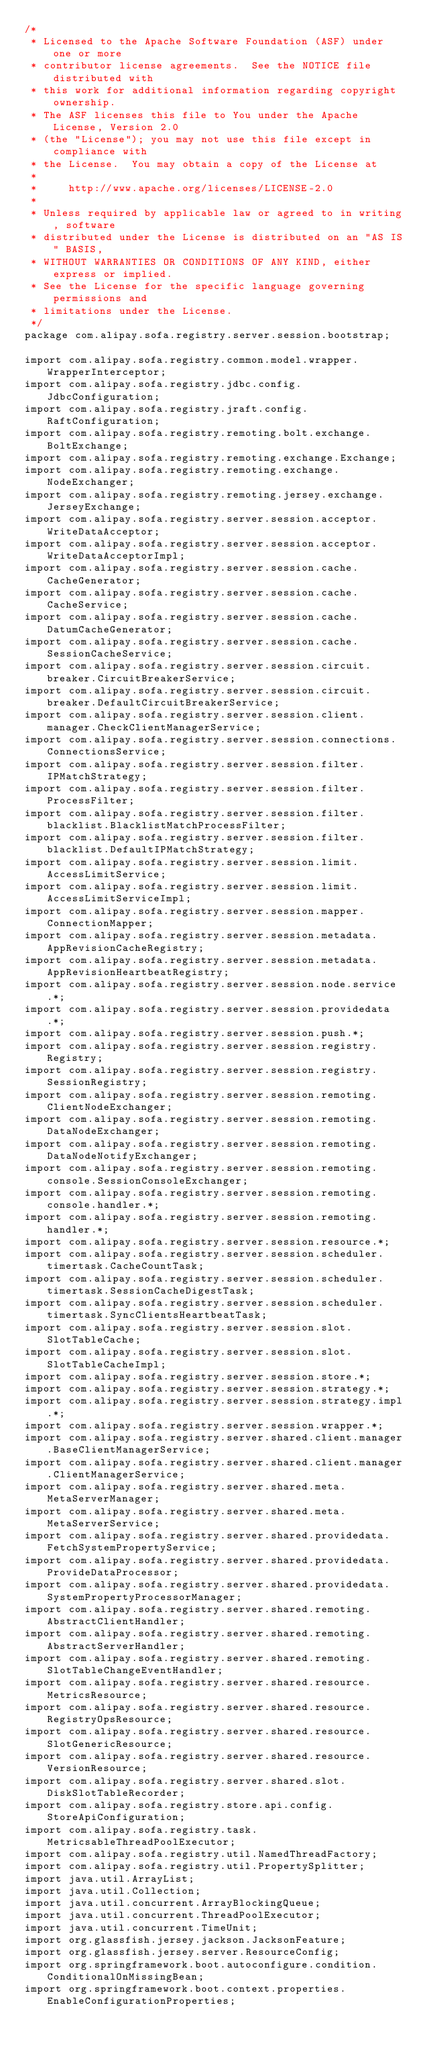<code> <loc_0><loc_0><loc_500><loc_500><_Java_>/*
 * Licensed to the Apache Software Foundation (ASF) under one or more
 * contributor license agreements.  See the NOTICE file distributed with
 * this work for additional information regarding copyright ownership.
 * The ASF licenses this file to You under the Apache License, Version 2.0
 * (the "License"); you may not use this file except in compliance with
 * the License.  You may obtain a copy of the License at
 *
 *     http://www.apache.org/licenses/LICENSE-2.0
 *
 * Unless required by applicable law or agreed to in writing, software
 * distributed under the License is distributed on an "AS IS" BASIS,
 * WITHOUT WARRANTIES OR CONDITIONS OF ANY KIND, either express or implied.
 * See the License for the specific language governing permissions and
 * limitations under the License.
 */
package com.alipay.sofa.registry.server.session.bootstrap;

import com.alipay.sofa.registry.common.model.wrapper.WrapperInterceptor;
import com.alipay.sofa.registry.jdbc.config.JdbcConfiguration;
import com.alipay.sofa.registry.jraft.config.RaftConfiguration;
import com.alipay.sofa.registry.remoting.bolt.exchange.BoltExchange;
import com.alipay.sofa.registry.remoting.exchange.Exchange;
import com.alipay.sofa.registry.remoting.exchange.NodeExchanger;
import com.alipay.sofa.registry.remoting.jersey.exchange.JerseyExchange;
import com.alipay.sofa.registry.server.session.acceptor.WriteDataAcceptor;
import com.alipay.sofa.registry.server.session.acceptor.WriteDataAcceptorImpl;
import com.alipay.sofa.registry.server.session.cache.CacheGenerator;
import com.alipay.sofa.registry.server.session.cache.CacheService;
import com.alipay.sofa.registry.server.session.cache.DatumCacheGenerator;
import com.alipay.sofa.registry.server.session.cache.SessionCacheService;
import com.alipay.sofa.registry.server.session.circuit.breaker.CircuitBreakerService;
import com.alipay.sofa.registry.server.session.circuit.breaker.DefaultCircuitBreakerService;
import com.alipay.sofa.registry.server.session.client.manager.CheckClientManagerService;
import com.alipay.sofa.registry.server.session.connections.ConnectionsService;
import com.alipay.sofa.registry.server.session.filter.IPMatchStrategy;
import com.alipay.sofa.registry.server.session.filter.ProcessFilter;
import com.alipay.sofa.registry.server.session.filter.blacklist.BlacklistMatchProcessFilter;
import com.alipay.sofa.registry.server.session.filter.blacklist.DefaultIPMatchStrategy;
import com.alipay.sofa.registry.server.session.limit.AccessLimitService;
import com.alipay.sofa.registry.server.session.limit.AccessLimitServiceImpl;
import com.alipay.sofa.registry.server.session.mapper.ConnectionMapper;
import com.alipay.sofa.registry.server.session.metadata.AppRevisionCacheRegistry;
import com.alipay.sofa.registry.server.session.metadata.AppRevisionHeartbeatRegistry;
import com.alipay.sofa.registry.server.session.node.service.*;
import com.alipay.sofa.registry.server.session.providedata.*;
import com.alipay.sofa.registry.server.session.push.*;
import com.alipay.sofa.registry.server.session.registry.Registry;
import com.alipay.sofa.registry.server.session.registry.SessionRegistry;
import com.alipay.sofa.registry.server.session.remoting.ClientNodeExchanger;
import com.alipay.sofa.registry.server.session.remoting.DataNodeExchanger;
import com.alipay.sofa.registry.server.session.remoting.DataNodeNotifyExchanger;
import com.alipay.sofa.registry.server.session.remoting.console.SessionConsoleExchanger;
import com.alipay.sofa.registry.server.session.remoting.console.handler.*;
import com.alipay.sofa.registry.server.session.remoting.handler.*;
import com.alipay.sofa.registry.server.session.resource.*;
import com.alipay.sofa.registry.server.session.scheduler.timertask.CacheCountTask;
import com.alipay.sofa.registry.server.session.scheduler.timertask.SessionCacheDigestTask;
import com.alipay.sofa.registry.server.session.scheduler.timertask.SyncClientsHeartbeatTask;
import com.alipay.sofa.registry.server.session.slot.SlotTableCache;
import com.alipay.sofa.registry.server.session.slot.SlotTableCacheImpl;
import com.alipay.sofa.registry.server.session.store.*;
import com.alipay.sofa.registry.server.session.strategy.*;
import com.alipay.sofa.registry.server.session.strategy.impl.*;
import com.alipay.sofa.registry.server.session.wrapper.*;
import com.alipay.sofa.registry.server.shared.client.manager.BaseClientManagerService;
import com.alipay.sofa.registry.server.shared.client.manager.ClientManagerService;
import com.alipay.sofa.registry.server.shared.meta.MetaServerManager;
import com.alipay.sofa.registry.server.shared.meta.MetaServerService;
import com.alipay.sofa.registry.server.shared.providedata.FetchSystemPropertyService;
import com.alipay.sofa.registry.server.shared.providedata.ProvideDataProcessor;
import com.alipay.sofa.registry.server.shared.providedata.SystemPropertyProcessorManager;
import com.alipay.sofa.registry.server.shared.remoting.AbstractClientHandler;
import com.alipay.sofa.registry.server.shared.remoting.AbstractServerHandler;
import com.alipay.sofa.registry.server.shared.remoting.SlotTableChangeEventHandler;
import com.alipay.sofa.registry.server.shared.resource.MetricsResource;
import com.alipay.sofa.registry.server.shared.resource.RegistryOpsResource;
import com.alipay.sofa.registry.server.shared.resource.SlotGenericResource;
import com.alipay.sofa.registry.server.shared.resource.VersionResource;
import com.alipay.sofa.registry.server.shared.slot.DiskSlotTableRecorder;
import com.alipay.sofa.registry.store.api.config.StoreApiConfiguration;
import com.alipay.sofa.registry.task.MetricsableThreadPoolExecutor;
import com.alipay.sofa.registry.util.NamedThreadFactory;
import com.alipay.sofa.registry.util.PropertySplitter;
import java.util.ArrayList;
import java.util.Collection;
import java.util.concurrent.ArrayBlockingQueue;
import java.util.concurrent.ThreadPoolExecutor;
import java.util.concurrent.TimeUnit;
import org.glassfish.jersey.jackson.JacksonFeature;
import org.glassfish.jersey.server.ResourceConfig;
import org.springframework.boot.autoconfigure.condition.ConditionalOnMissingBean;
import org.springframework.boot.context.properties.EnableConfigurationProperties;</code> 